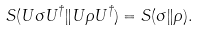Convert formula to latex. <formula><loc_0><loc_0><loc_500><loc_500>S ( U \sigma U ^ { \dagger } \| U \rho U ^ { \dagger } ) = S ( \sigma \| \rho ) .</formula> 